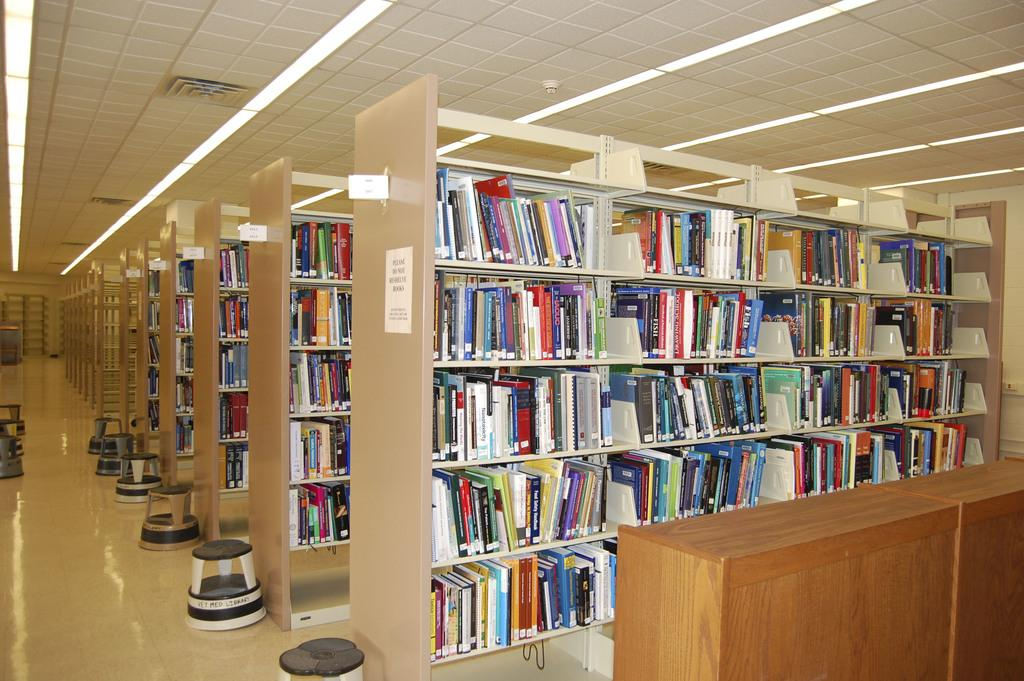What type of furniture is present in the image? There is a table and stools in the image. What type of storage units are visible in the image? There are cupboards in the image. What items can be found inside the cupboards? Books are present in the cupboards. What type of location might the image be taken in? The image appears to be taken in a library hall. What can be seen at the top of the image? There is a rooftop visible at the top of the image. How much money is on the table in the image? There is no money visible on the table in the image. What type of skirt is draped over the stool in the image? There is no skirt present in the image. 